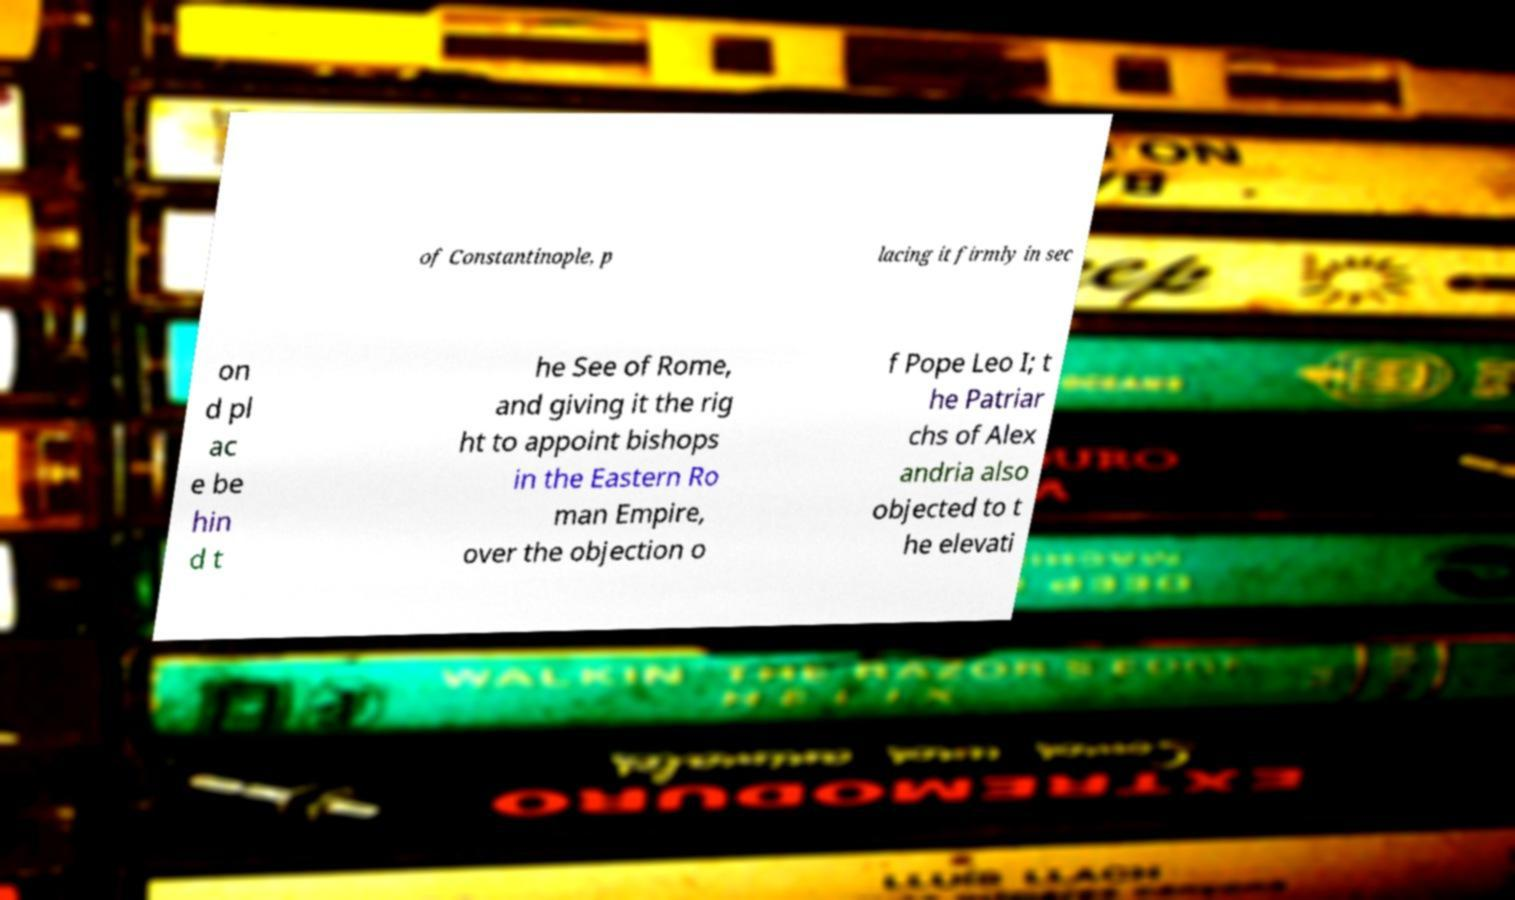Please identify and transcribe the text found in this image. of Constantinople, p lacing it firmly in sec on d pl ac e be hin d t he See of Rome, and giving it the rig ht to appoint bishops in the Eastern Ro man Empire, over the objection o f Pope Leo I; t he Patriar chs of Alex andria also objected to t he elevati 